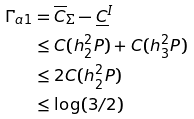<formula> <loc_0><loc_0><loc_500><loc_500>\Gamma _ { a 1 } & = \overline { C } _ { \Sigma } - \underline { C } ^ { I } \\ & \leq C ( h _ { 2 } ^ { 2 } P ) + C ( h _ { 3 } ^ { 2 } P ) \\ & \leq 2 C ( h _ { 2 } ^ { 2 } P ) \\ & \leq \log ( 3 / 2 )</formula> 